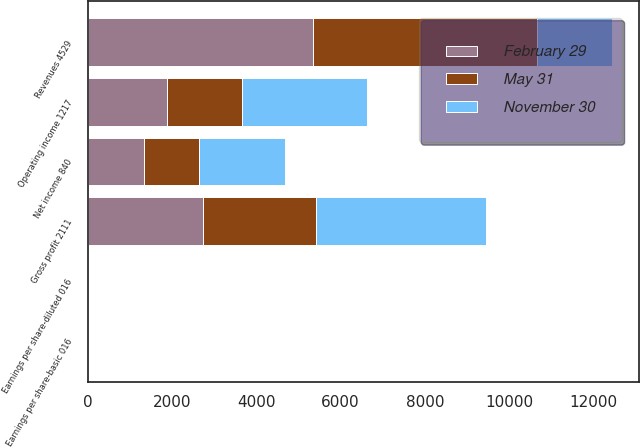Convert chart to OTSL. <chart><loc_0><loc_0><loc_500><loc_500><stacked_bar_chart><ecel><fcel>Revenues 4529<fcel>Gross profit 2111<fcel>Operating income 1217<fcel>Net income 840<fcel>Earnings per share-basic 016<fcel>Earnings per share-diluted 016<nl><fcel>May 31<fcel>5313<fcel>2690<fcel>1782<fcel>1303<fcel>0.25<fcel>0.25<nl><fcel>February 29<fcel>5349<fcel>2731<fcel>1875<fcel>1340<fcel>0.26<fcel>0.26<nl><fcel>November 30<fcel>1782<fcel>4028<fcel>2971<fcel>2037<fcel>0.4<fcel>0.39<nl></chart> 